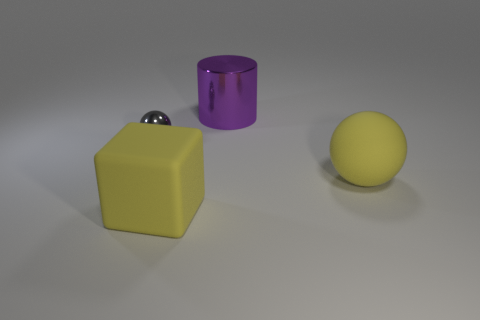Add 4 yellow matte cubes. How many objects exist? 8 Add 2 gray objects. How many gray objects are left? 3 Add 2 gray blocks. How many gray blocks exist? 2 Subtract 0 cyan blocks. How many objects are left? 4 Subtract all cubes. How many objects are left? 3 Subtract all green spheres. Subtract all brown cylinders. How many spheres are left? 2 Subtract all small metallic balls. Subtract all blocks. How many objects are left? 2 